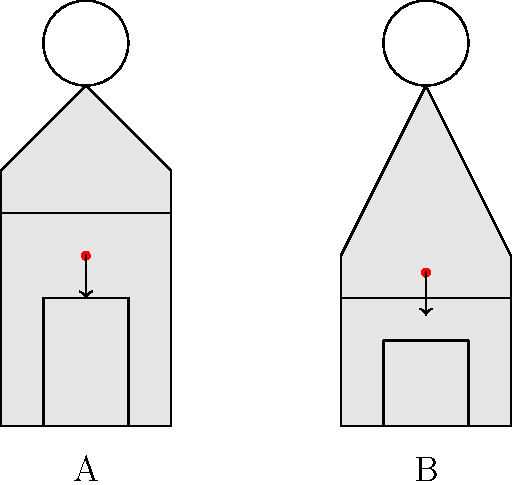In the context of character design for a mod-friendly game, consider the two character outlines A and B shown above. How does the difference in body proportions affect their centers of gravity, and what implications might this have for character movement and balance in the game? To understand the impact of body proportions on a character's center of gravity (CoG), let's analyze the two character outlines:

1. Character A:
   - Has a more evenly distributed body mass
   - Longer torso and legs
   - CoG is approximately at the middle of the torso

2. Character B:
   - Has a more top-heavy design
   - Shorter legs and a larger upper body
   - CoG is higher, closer to the chest area

The center of gravity affects character movement and balance in the following ways:

1. Stability: Character A will be more stable due to its lower CoG. This could translate to better balance and resistance to knockbacks in the game.

2. Agility: Character B might be less agile due to its higher CoG, potentially making quick direction changes more challenging.

3. Jump mechanics: Character A might have an advantage in jumping due to its longer legs and lower CoG, allowing for more powerful jumps.

4. Animation considerations: Character B's movements might need to be more exaggerated to maintain balance, especially during rapid movements or turns.

5. Mod potential: The different body proportions offer diverse opportunities for modders to create unique gameplay experiences. For example:
   - Character A could be modded for agility-based classes or stealth gameplay.
   - Character B could be modded for strength-based classes or characters with special upper body abilities.

6. Physics interactions: In-game physics might need to be adjusted to account for the different CoGs, affecting how characters interact with the environment and each other.

7. Customization options: Players could potentially adjust body proportions, allowing them to fine-tune character performance based on CoG placement.

By understanding these implications, game designers and modders can create more diverse and engaging gameplay experiences that take advantage of the characters' unique physical characteristics.
Answer: Different body proportions shift the center of gravity, affecting stability, agility, and movement, which influences gameplay mechanics and mod potential. 